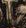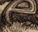Read the text from these images in sequence, separated by a semicolon. #; e 